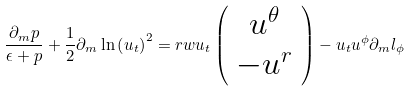Convert formula to latex. <formula><loc_0><loc_0><loc_500><loc_500>\frac { \partial _ { m } p } { \epsilon + p } + \frac { 1 } { 2 } \partial _ { m } \ln \left ( u _ { t } \right ) ^ { 2 } = r w u _ { t } \left ( \begin{array} { c } u ^ { \theta } \\ - u ^ { r } \end{array} \right ) - u _ { t } u ^ { \phi } \partial _ { m } l _ { \phi }</formula> 